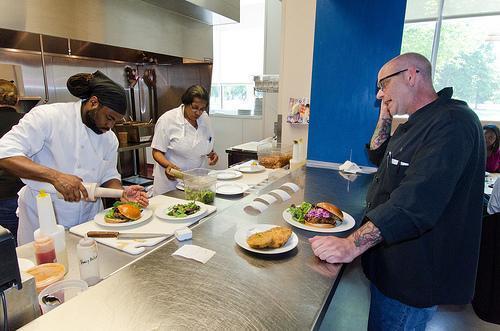How many people are in the photograph?
Give a very brief answer. 3. 